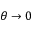Convert formula to latex. <formula><loc_0><loc_0><loc_500><loc_500>\theta \rightarrow 0</formula> 